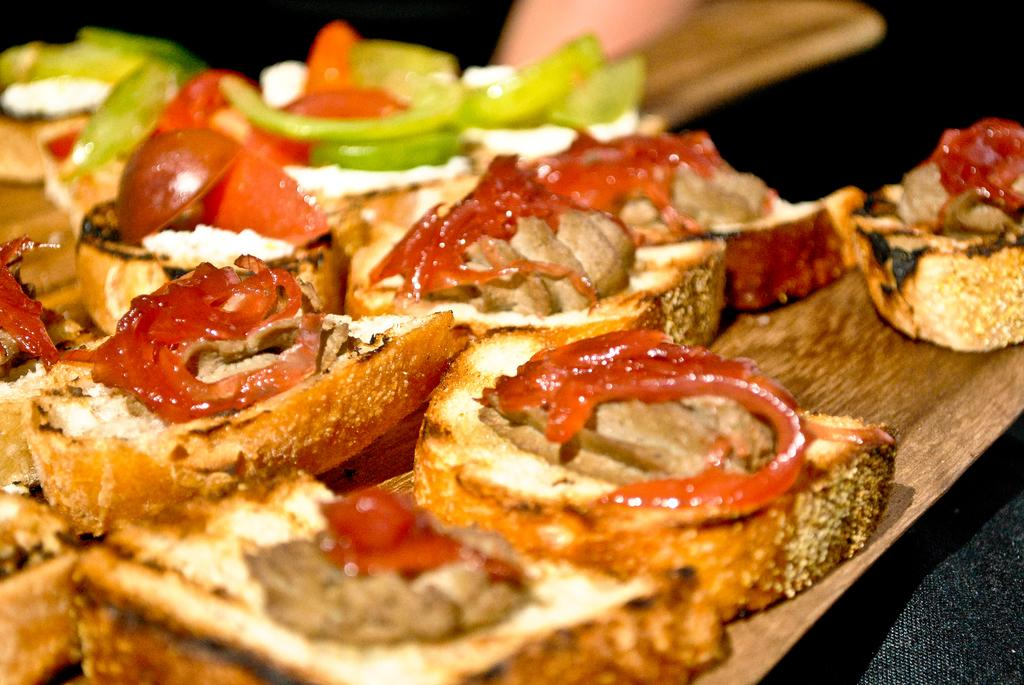What is on the wooden tray in the image? There is food on a wooden tray in the image. Can you describe the type of food on the tray? There are veggies on the tray. Who is holding the wooden tray? A human is holding the tray. What type of milk can be seen being poured from the church in the image? There is no church or milk present in the image; it features a wooden tray with veggies being held by a human. 